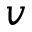Convert formula to latex. <formula><loc_0><loc_0><loc_500><loc_500>v</formula> 